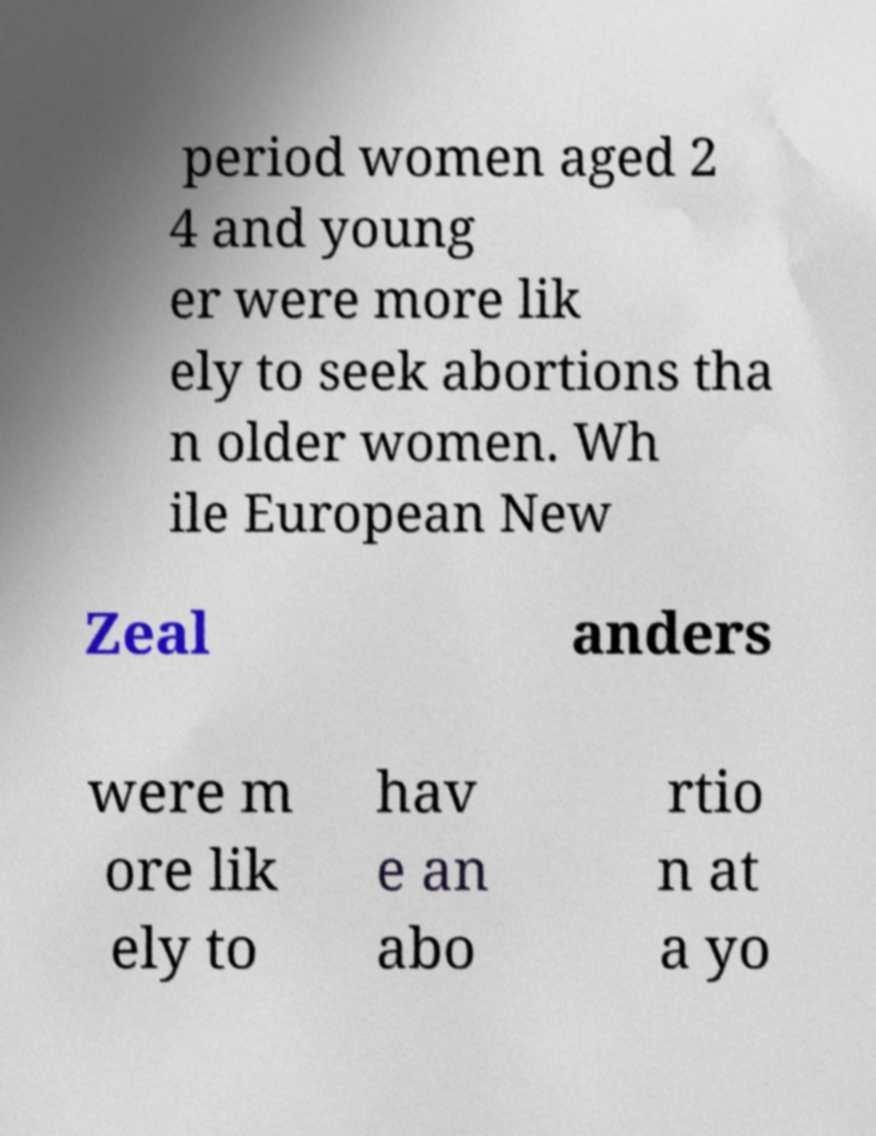Please identify and transcribe the text found in this image. period women aged 2 4 and young er were more lik ely to seek abortions tha n older women. Wh ile European New Zeal anders were m ore lik ely to hav e an abo rtio n at a yo 